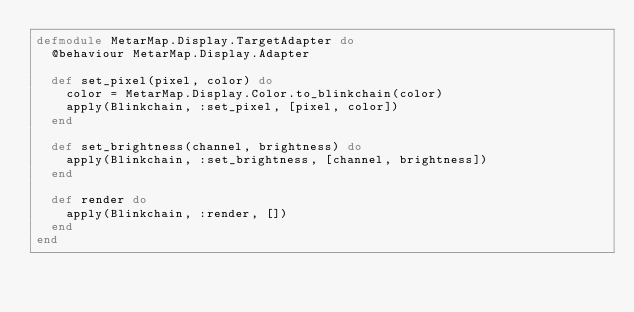<code> <loc_0><loc_0><loc_500><loc_500><_Elixir_>defmodule MetarMap.Display.TargetAdapter do
  @behaviour MetarMap.Display.Adapter

  def set_pixel(pixel, color) do
    color = MetarMap.Display.Color.to_blinkchain(color)
    apply(Blinkchain, :set_pixel, [pixel, color])
  end

  def set_brightness(channel, brightness) do
    apply(Blinkchain, :set_brightness, [channel, brightness])
  end

  def render do
    apply(Blinkchain, :render, [])
  end
end
</code> 